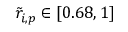<formula> <loc_0><loc_0><loc_500><loc_500>\tilde { r } _ { i , p } \in [ 0 . 6 8 , 1 ]</formula> 